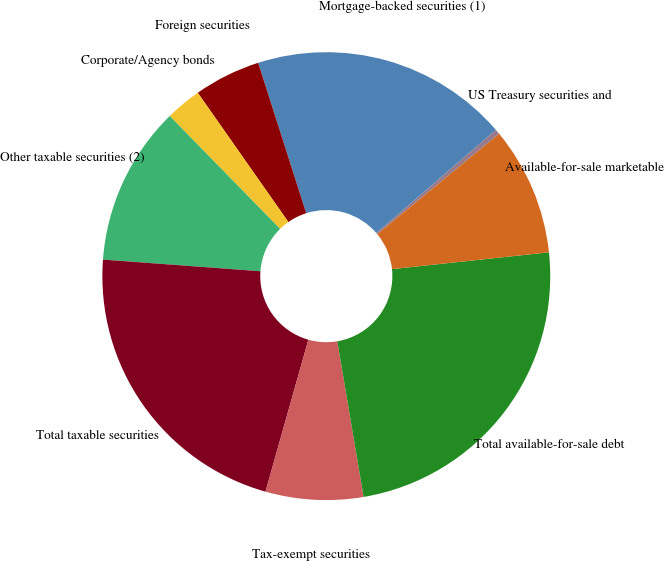Convert chart to OTSL. <chart><loc_0><loc_0><loc_500><loc_500><pie_chart><fcel>US Treasury securities and<fcel>Mortgage-backed securities (1)<fcel>Foreign securities<fcel>Corporate/Agency bonds<fcel>Other taxable securities (2)<fcel>Total taxable securities<fcel>Tax-exempt securities<fcel>Total available-for-sale debt<fcel>Available-for-sale marketable<nl><fcel>0.36%<fcel>18.59%<fcel>4.81%<fcel>2.59%<fcel>11.5%<fcel>21.8%<fcel>7.04%<fcel>24.03%<fcel>9.27%<nl></chart> 